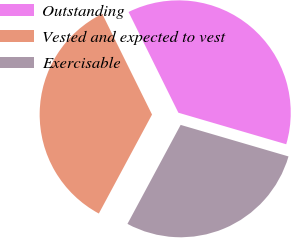<chart> <loc_0><loc_0><loc_500><loc_500><pie_chart><fcel>Outstanding<fcel>Vested and expected to vest<fcel>Exercisable<nl><fcel>36.84%<fcel>34.84%<fcel>28.32%<nl></chart> 